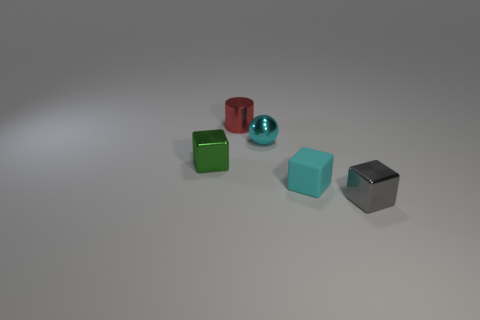Add 4 cyan cubes. How many objects exist? 9 Subtract all spheres. How many objects are left? 4 Subtract all green metallic blocks. Subtract all small cyan balls. How many objects are left? 3 Add 2 cylinders. How many cylinders are left? 3 Add 3 large blue blocks. How many large blue blocks exist? 3 Subtract 1 gray cubes. How many objects are left? 4 